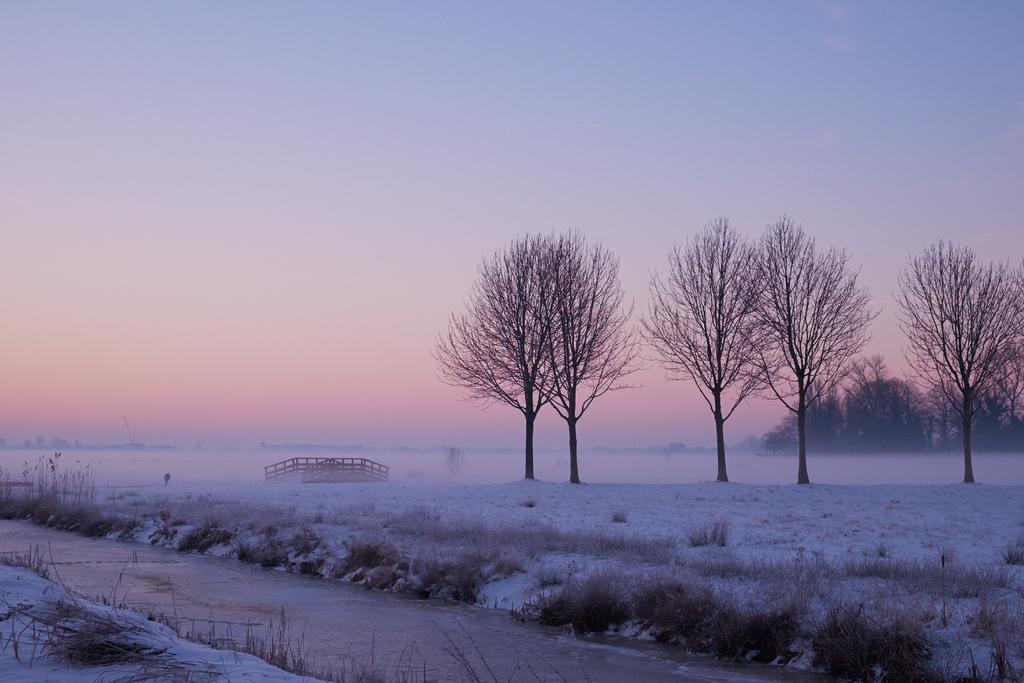Describe this image in one or two sentences. In this image we can see trees, grass, snow and other objects. At the bottom of the image there is the grass, plants, walkway and snow. At the top of the image there is the sky. 